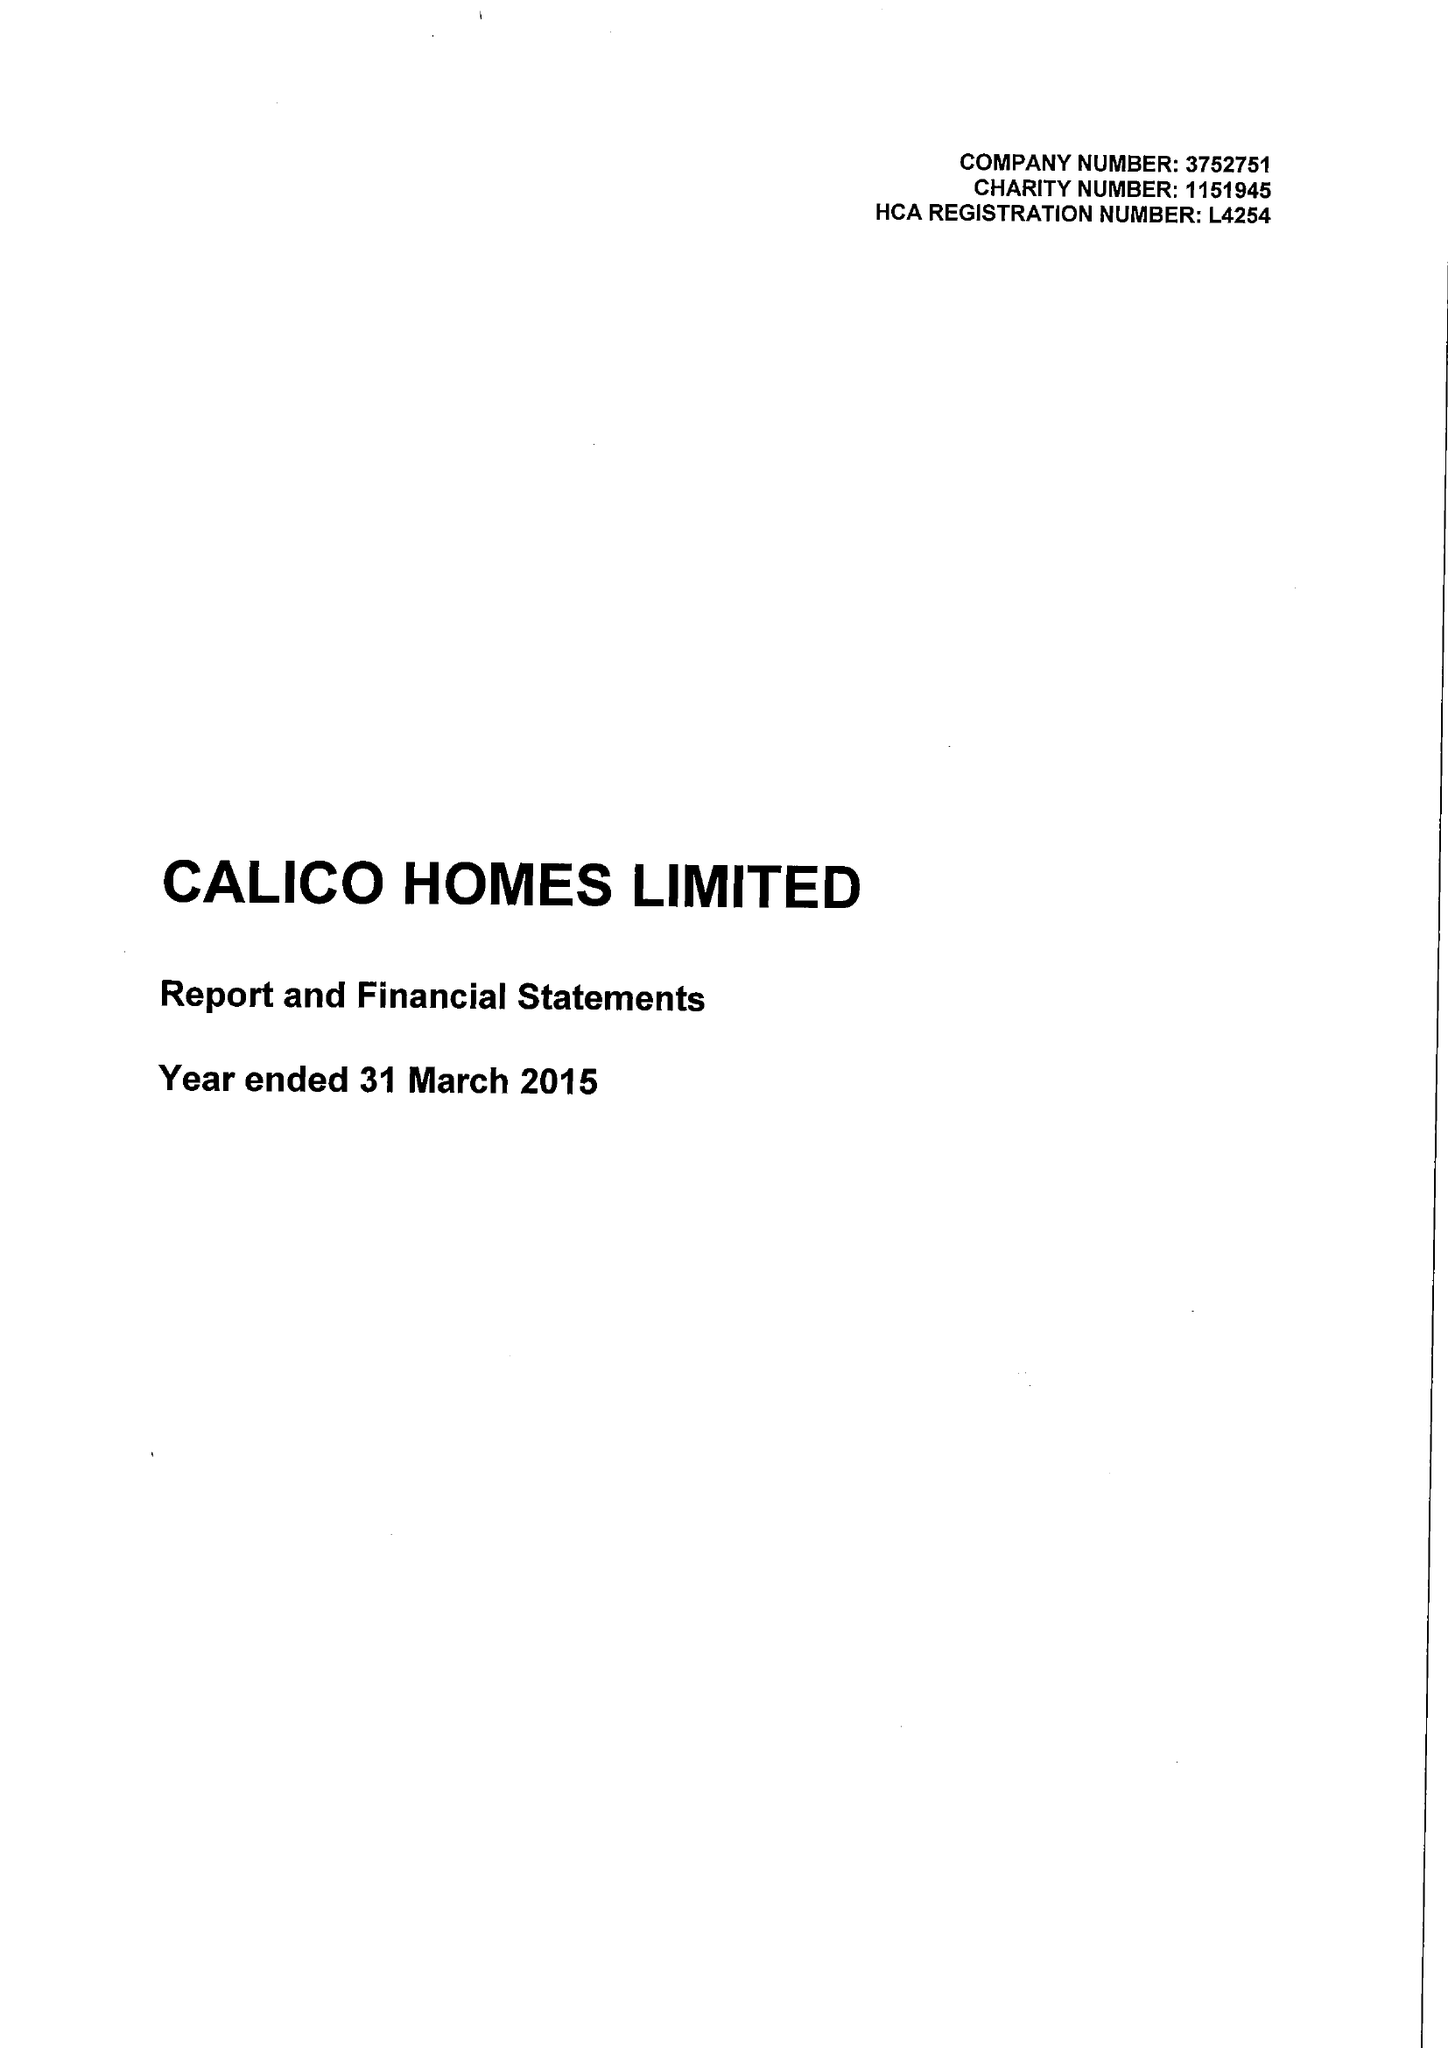What is the value for the report_date?
Answer the question using a single word or phrase. 2015-03-31 